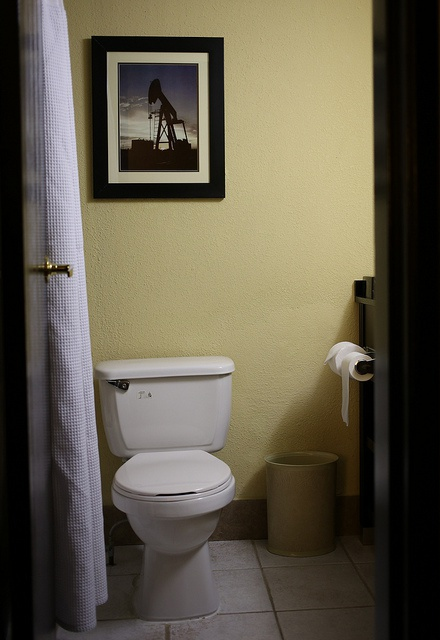Describe the objects in this image and their specific colors. I can see a toilet in black, darkgray, and gray tones in this image. 